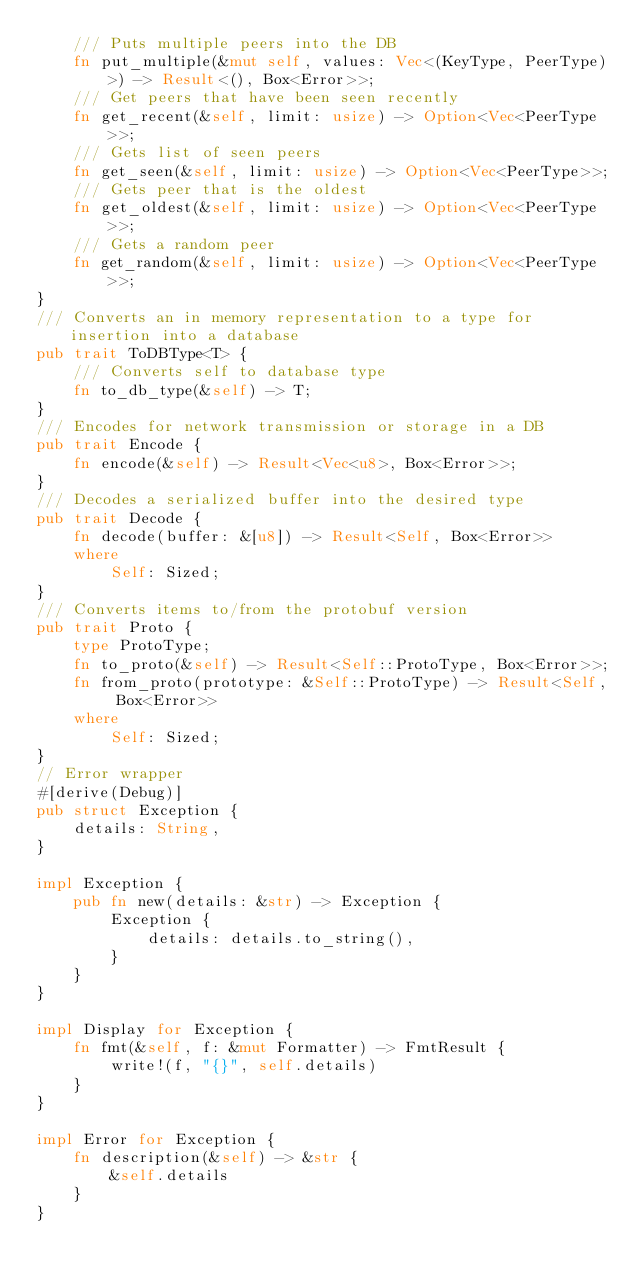<code> <loc_0><loc_0><loc_500><loc_500><_Rust_>    /// Puts multiple peers into the DB
    fn put_multiple(&mut self, values: Vec<(KeyType, PeerType)>) -> Result<(), Box<Error>>;
    /// Get peers that have been seen recently
    fn get_recent(&self, limit: usize) -> Option<Vec<PeerType>>;
    /// Gets list of seen peers
    fn get_seen(&self, limit: usize) -> Option<Vec<PeerType>>;
    /// Gets peer that is the oldest
    fn get_oldest(&self, limit: usize) -> Option<Vec<PeerType>>;
    /// Gets a random peer
    fn get_random(&self, limit: usize) -> Option<Vec<PeerType>>;
}
/// Converts an in memory representation to a type for insertion into a database
pub trait ToDBType<T> {
    /// Converts self to database type
    fn to_db_type(&self) -> T;
}
/// Encodes for network transmission or storage in a DB
pub trait Encode {
    fn encode(&self) -> Result<Vec<u8>, Box<Error>>;
}
/// Decodes a serialized buffer into the desired type
pub trait Decode {
    fn decode(buffer: &[u8]) -> Result<Self, Box<Error>>
    where
        Self: Sized;
}
/// Converts items to/from the protobuf version
pub trait Proto {
    type ProtoType;
    fn to_proto(&self) -> Result<Self::ProtoType, Box<Error>>;
    fn from_proto(prototype: &Self::ProtoType) -> Result<Self, Box<Error>>
    where
        Self: Sized;
}
// Error wrapper
#[derive(Debug)]
pub struct Exception {
    details: String,
}

impl Exception {
    pub fn new(details: &str) -> Exception {
        Exception {
            details: details.to_string(),
        }
    }
}

impl Display for Exception {
    fn fmt(&self, f: &mut Formatter) -> FmtResult {
        write!(f, "{}", self.details)
    }
}

impl Error for Exception {
    fn description(&self) -> &str {
        &self.details
    }
}
</code> 